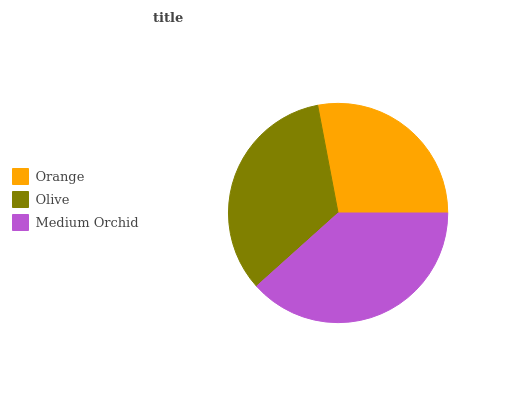Is Orange the minimum?
Answer yes or no. Yes. Is Medium Orchid the maximum?
Answer yes or no. Yes. Is Olive the minimum?
Answer yes or no. No. Is Olive the maximum?
Answer yes or no. No. Is Olive greater than Orange?
Answer yes or no. Yes. Is Orange less than Olive?
Answer yes or no. Yes. Is Orange greater than Olive?
Answer yes or no. No. Is Olive less than Orange?
Answer yes or no. No. Is Olive the high median?
Answer yes or no. Yes. Is Olive the low median?
Answer yes or no. Yes. Is Medium Orchid the high median?
Answer yes or no. No. Is Orange the low median?
Answer yes or no. No. 